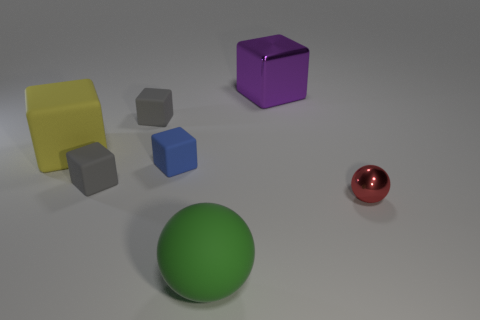What number of things are either balls that are to the right of the big purple metallic thing or spheres on the right side of the purple metal cube? In the scene, there is one large green sphere positioned to the right of the big purple metallic cube, and one small red ball also situated on the right-hand side of the purple object. This makes the total count of such items 2. 